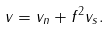Convert formula to latex. <formula><loc_0><loc_0><loc_500><loc_500>v = v _ { n } + f ^ { 2 } v _ { s } .</formula> 